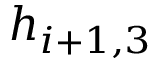<formula> <loc_0><loc_0><loc_500><loc_500>h _ { i + 1 , 3 }</formula> 